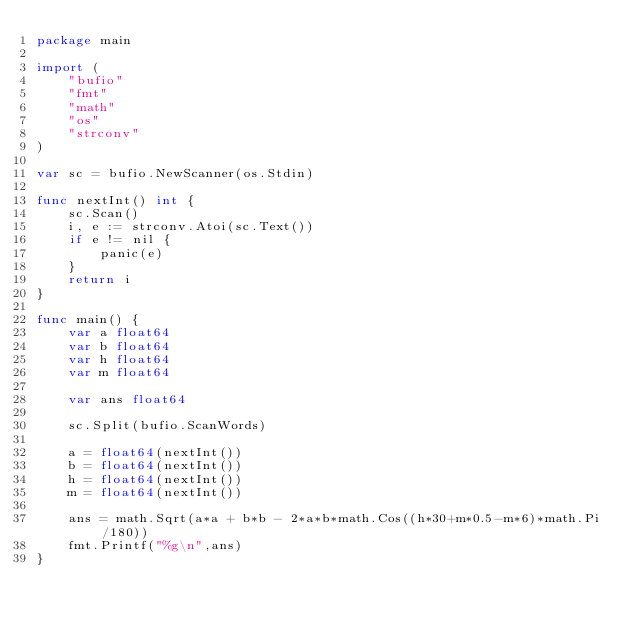<code> <loc_0><loc_0><loc_500><loc_500><_Go_>package main

import (
	"bufio"
	"fmt"
	"math"
	"os"
	"strconv"
)

var sc = bufio.NewScanner(os.Stdin)

func nextInt() int {
	sc.Scan()
	i, e := strconv.Atoi(sc.Text())
	if e != nil {
		panic(e)
	}
	return i
}

func main() {
	var a float64
	var b float64
	var h float64
	var m float64

	var ans float64

	sc.Split(bufio.ScanWords)

	a = float64(nextInt())
	b = float64(nextInt())
	h = float64(nextInt())
	m = float64(nextInt())

	ans = math.Sqrt(a*a + b*b - 2*a*b*math.Cos((h*30+m*0.5-m*6)*math.Pi/180))
	fmt.Printf("%g\n",ans)
}</code> 